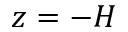Convert formula to latex. <formula><loc_0><loc_0><loc_500><loc_500>z = - H</formula> 